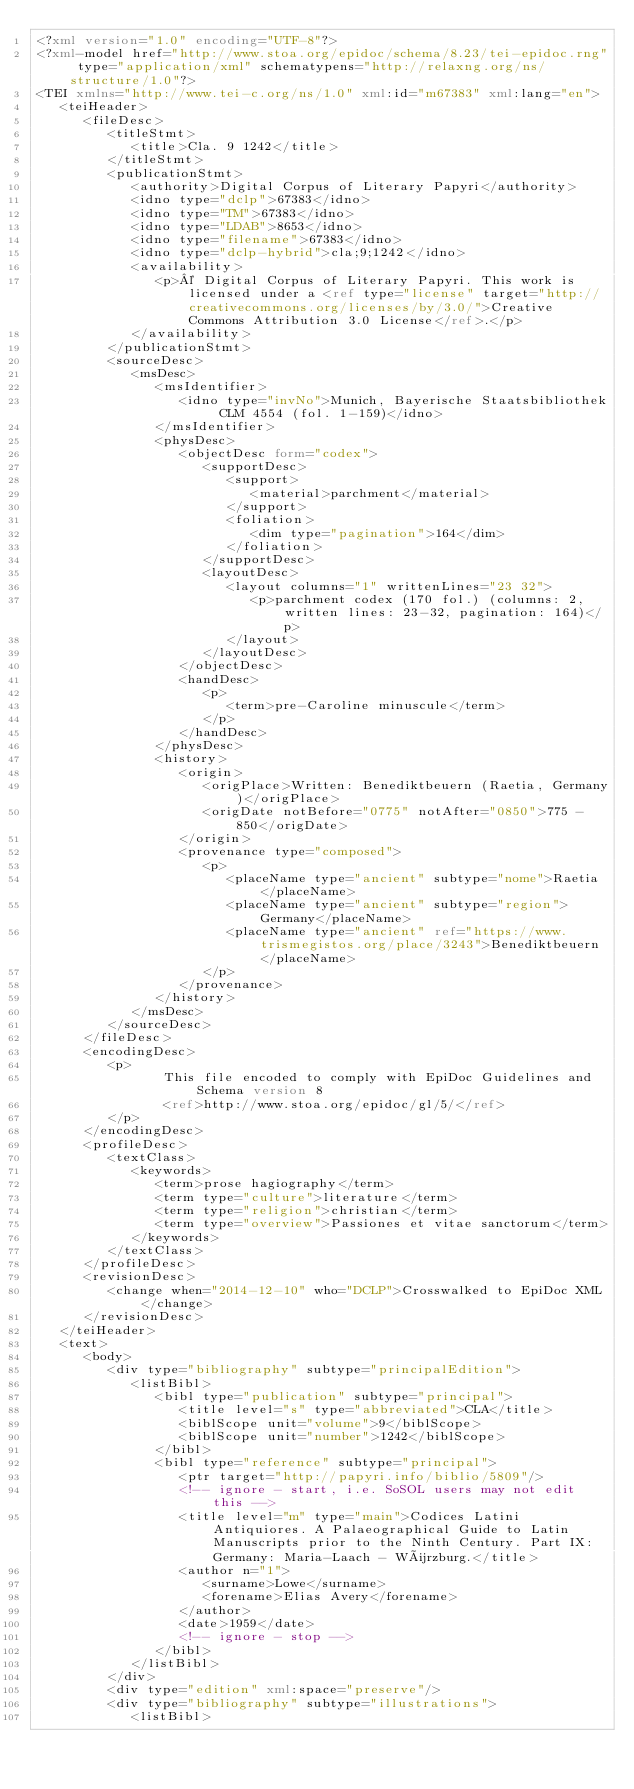<code> <loc_0><loc_0><loc_500><loc_500><_XML_><?xml version="1.0" encoding="UTF-8"?>
<?xml-model href="http://www.stoa.org/epidoc/schema/8.23/tei-epidoc.rng" type="application/xml" schematypens="http://relaxng.org/ns/structure/1.0"?>
<TEI xmlns="http://www.tei-c.org/ns/1.0" xml:id="m67383" xml:lang="en">
   <teiHeader>
      <fileDesc>
         <titleStmt>
            <title>Cla. 9 1242</title>
         </titleStmt>
         <publicationStmt>
            <authority>Digital Corpus of Literary Papyri</authority>
            <idno type="dclp">67383</idno>
            <idno type="TM">67383</idno>
            <idno type="LDAB">8653</idno>
            <idno type="filename">67383</idno>
            <idno type="dclp-hybrid">cla;9;1242</idno>
            <availability>
               <p>© Digital Corpus of Literary Papyri. This work is licensed under a <ref type="license" target="http://creativecommons.org/licenses/by/3.0/">Creative Commons Attribution 3.0 License</ref>.</p>
            </availability>
         </publicationStmt>
         <sourceDesc>
            <msDesc>
               <msIdentifier>
                  <idno type="invNo">Munich, Bayerische Staatsbibliothek CLM 4554 (fol. 1-159)</idno>
               </msIdentifier>
               <physDesc>
                  <objectDesc form="codex">
                     <supportDesc>
                        <support>
                           <material>parchment</material>
                        </support>
                        <foliation>
                           <dim type="pagination">164</dim>
                        </foliation>
                     </supportDesc>
                     <layoutDesc>
                        <layout columns="1" writtenLines="23 32">
                           <p>parchment codex (170 fol.) (columns: 2, written lines: 23-32, pagination: 164)</p>
                        </layout>
                     </layoutDesc>
                  </objectDesc>
                  <handDesc>
                     <p>
                        <term>pre-Caroline minuscule</term>
                     </p>
                  </handDesc>
               </physDesc>
               <history>
                  <origin>
                     <origPlace>Written: Benediktbeuern (Raetia, Germany)</origPlace>
                     <origDate notBefore="0775" notAfter="0850">775 - 850</origDate>
                  </origin>
                  <provenance type="composed">
                     <p>
                        <placeName type="ancient" subtype="nome">Raetia</placeName>
                        <placeName type="ancient" subtype="region">Germany</placeName>
                        <placeName type="ancient" ref="https://www.trismegistos.org/place/3243">Benediktbeuern</placeName>
                     </p>
                  </provenance>
               </history>
            </msDesc>
         </sourceDesc>
      </fileDesc>
      <encodingDesc>
         <p>
                This file encoded to comply with EpiDoc Guidelines and Schema version 8
                <ref>http://www.stoa.org/epidoc/gl/5/</ref>
         </p>
      </encodingDesc>
      <profileDesc>
         <textClass>
            <keywords>
               <term>prose hagiography</term>
               <term type="culture">literature</term>
               <term type="religion">christian</term>
               <term type="overview">Passiones et vitae sanctorum</term>
            </keywords>
         </textClass>
      </profileDesc>
      <revisionDesc>
         <change when="2014-12-10" who="DCLP">Crosswalked to EpiDoc XML</change>
      </revisionDesc>
   </teiHeader>
   <text>
      <body>
         <div type="bibliography" subtype="principalEdition">
            <listBibl>
               <bibl type="publication" subtype="principal">
                  <title level="s" type="abbreviated">CLA</title>
                  <biblScope unit="volume">9</biblScope>
                  <biblScope unit="number">1242</biblScope>
               </bibl>
               <bibl type="reference" subtype="principal">
                  <ptr target="http://papyri.info/biblio/5809"/>
                  <!-- ignore - start, i.e. SoSOL users may not edit this -->
                  <title level="m" type="main">Codices Latini Antiquiores. A Palaeographical Guide to Latin Manuscripts prior to the Ninth Century. Part IX: Germany: Maria-Laach - Würzburg.</title>
                  <author n="1">
                     <surname>Lowe</surname>
                     <forename>Elias Avery</forename>
                  </author>
                  <date>1959</date>
                  <!-- ignore - stop -->
               </bibl>
            </listBibl>
         </div>
         <div type="edition" xml:space="preserve"/>
         <div type="bibliography" subtype="illustrations">
            <listBibl></code> 